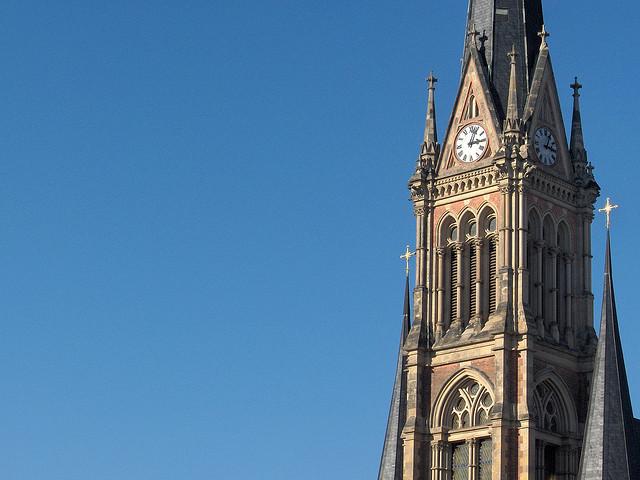What is in the middle of this picture?
Write a very short answer. Clock tower. How many crosses can be seen?
Answer briefly. 7. What is the time?
Give a very brief answer. 1:15. What time does it say?
Keep it brief. 3:05. Is the sky cloudy?
Be succinct. No. 